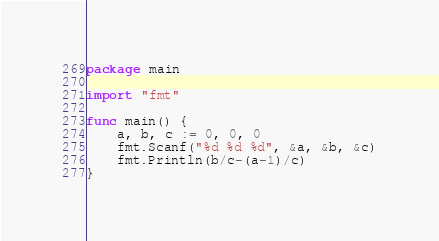Convert code to text. <code><loc_0><loc_0><loc_500><loc_500><_Go_>package main

import "fmt"

func main() {
	a, b, c := 0, 0, 0
	fmt.Scanf("%d %d %d", &a, &b, &c)
	fmt.Println(b/c-(a-1)/c)
}
</code> 